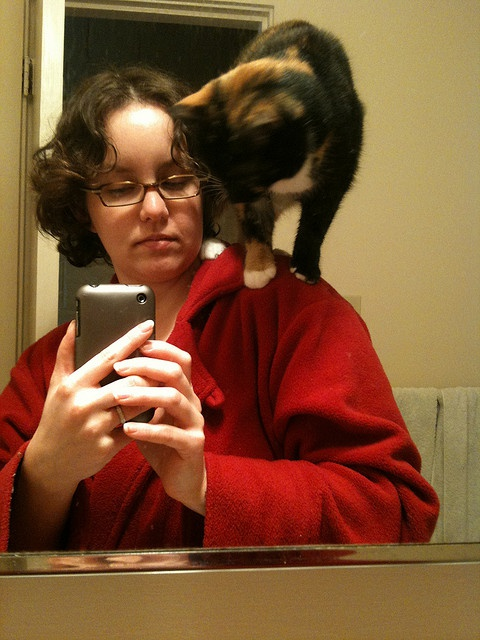Describe the objects in this image and their specific colors. I can see people in tan, maroon, brown, and black tones, cat in tan, black, olive, and maroon tones, and cell phone in tan, maroon, black, and ivory tones in this image. 